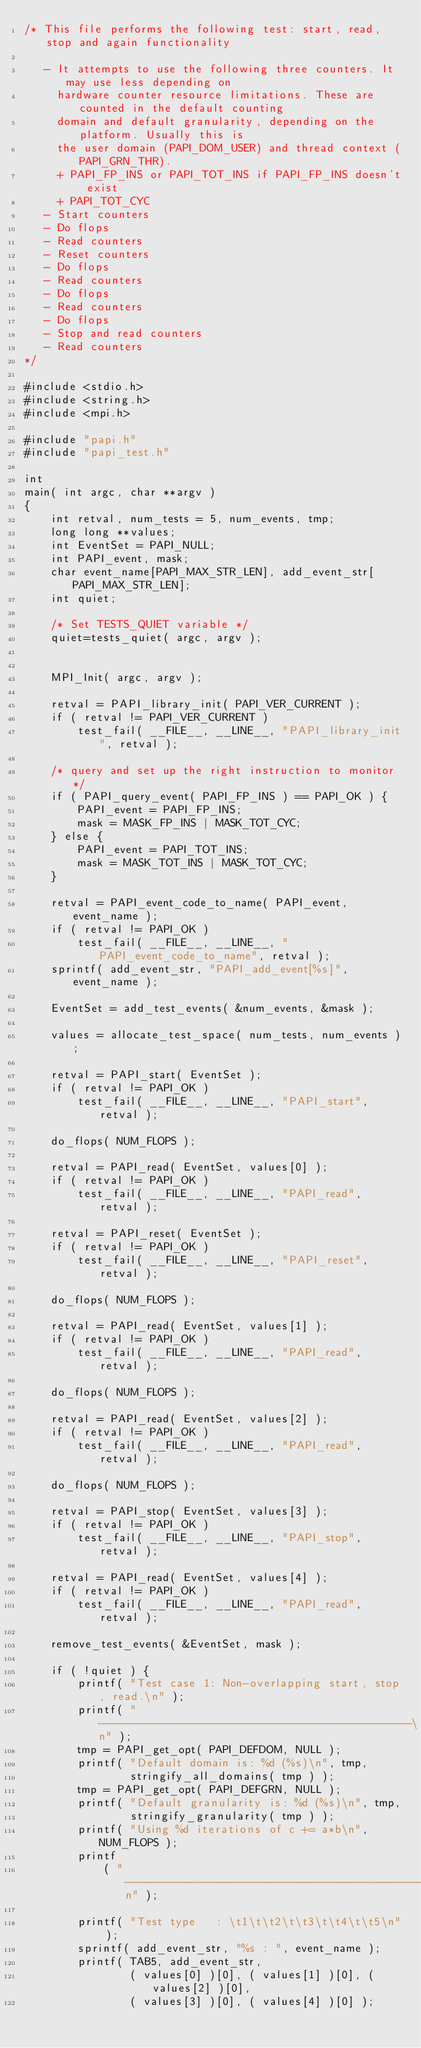<code> <loc_0><loc_0><loc_500><loc_500><_C_>/* This file performs the following test: start, read, stop and again functionality

   - It attempts to use the following three counters. It may use less depending on
     hardware counter resource limitations. These are counted in the default counting
     domain and default granularity, depending on the platform. Usually this is 
     the user domain (PAPI_DOM_USER) and thread context (PAPI_GRN_THR).
     + PAPI_FP_INS or PAPI_TOT_INS if PAPI_FP_INS doesn't exist
     + PAPI_TOT_CYC
   - Start counters
   - Do flops
   - Read counters
   - Reset counters
   - Do flops
   - Read counters
   - Do flops
   - Read counters
   - Do flops
   - Stop and read counters
   - Read counters
*/

#include <stdio.h>
#include <string.h>
#include <mpi.h>

#include "papi.h"
#include "papi_test.h"

int
main( int argc, char **argv )
{
	int retval, num_tests = 5, num_events, tmp;
	long long **values;
	int EventSet = PAPI_NULL;
	int PAPI_event, mask;
	char event_name[PAPI_MAX_STR_LEN], add_event_str[PAPI_MAX_STR_LEN];
	int quiet;

	/* Set TESTS_QUIET variable */
	quiet=tests_quiet( argc, argv );


	MPI_Init( argc, argv );

	retval = PAPI_library_init( PAPI_VER_CURRENT );
	if ( retval != PAPI_VER_CURRENT )
		test_fail( __FILE__, __LINE__, "PAPI_library_init", retval );

	/* query and set up the right instruction to monitor */
	if ( PAPI_query_event( PAPI_FP_INS ) == PAPI_OK ) {
		PAPI_event = PAPI_FP_INS;
		mask = MASK_FP_INS | MASK_TOT_CYC;
	} else {
		PAPI_event = PAPI_TOT_INS;
		mask = MASK_TOT_INS | MASK_TOT_CYC;
	}

	retval = PAPI_event_code_to_name( PAPI_event, event_name );
	if ( retval != PAPI_OK )
		test_fail( __FILE__, __LINE__, "PAPI_event_code_to_name", retval );
	sprintf( add_event_str, "PAPI_add_event[%s]", event_name );

	EventSet = add_test_events( &num_events, &mask );

	values = allocate_test_space( num_tests, num_events );

	retval = PAPI_start( EventSet );
	if ( retval != PAPI_OK )
		test_fail( __FILE__, __LINE__, "PAPI_start", retval );

	do_flops( NUM_FLOPS );

	retval = PAPI_read( EventSet, values[0] );
	if ( retval != PAPI_OK )
		test_fail( __FILE__, __LINE__, "PAPI_read", retval );

	retval = PAPI_reset( EventSet );
	if ( retval != PAPI_OK )
		test_fail( __FILE__, __LINE__, "PAPI_reset", retval );

	do_flops( NUM_FLOPS );

	retval = PAPI_read( EventSet, values[1] );
	if ( retval != PAPI_OK )
		test_fail( __FILE__, __LINE__, "PAPI_read", retval );

	do_flops( NUM_FLOPS );

	retval = PAPI_read( EventSet, values[2] );
	if ( retval != PAPI_OK )
		test_fail( __FILE__, __LINE__, "PAPI_read", retval );

	do_flops( NUM_FLOPS );

	retval = PAPI_stop( EventSet, values[3] );
	if ( retval != PAPI_OK )
		test_fail( __FILE__, __LINE__, "PAPI_stop", retval );

	retval = PAPI_read( EventSet, values[4] );
	if ( retval != PAPI_OK )
		test_fail( __FILE__, __LINE__, "PAPI_read", retval );

	remove_test_events( &EventSet, mask );

	if ( !quiet ) {
		printf( "Test case 1: Non-overlapping start, stop, read.\n" );
		printf( "-----------------------------------------------\n" );
		tmp = PAPI_get_opt( PAPI_DEFDOM, NULL );
		printf( "Default domain is: %d (%s)\n", tmp,
				stringify_all_domains( tmp ) );
		tmp = PAPI_get_opt( PAPI_DEFGRN, NULL );
		printf( "Default granularity is: %d (%s)\n", tmp,
				stringify_granularity( tmp ) );
		printf( "Using %d iterations of c += a*b\n", NUM_FLOPS );
		printf
			( "-------------------------------------------------------------------------\n" );

		printf( "Test type   : \t1\t\t2\t\t3\t\t4\t\t5\n" );
		sprintf( add_event_str, "%s : ", event_name );
		printf( TAB5, add_event_str,
				( values[0] )[0], ( values[1] )[0], ( values[2] )[0],
				( values[3] )[0], ( values[4] )[0] );</code> 